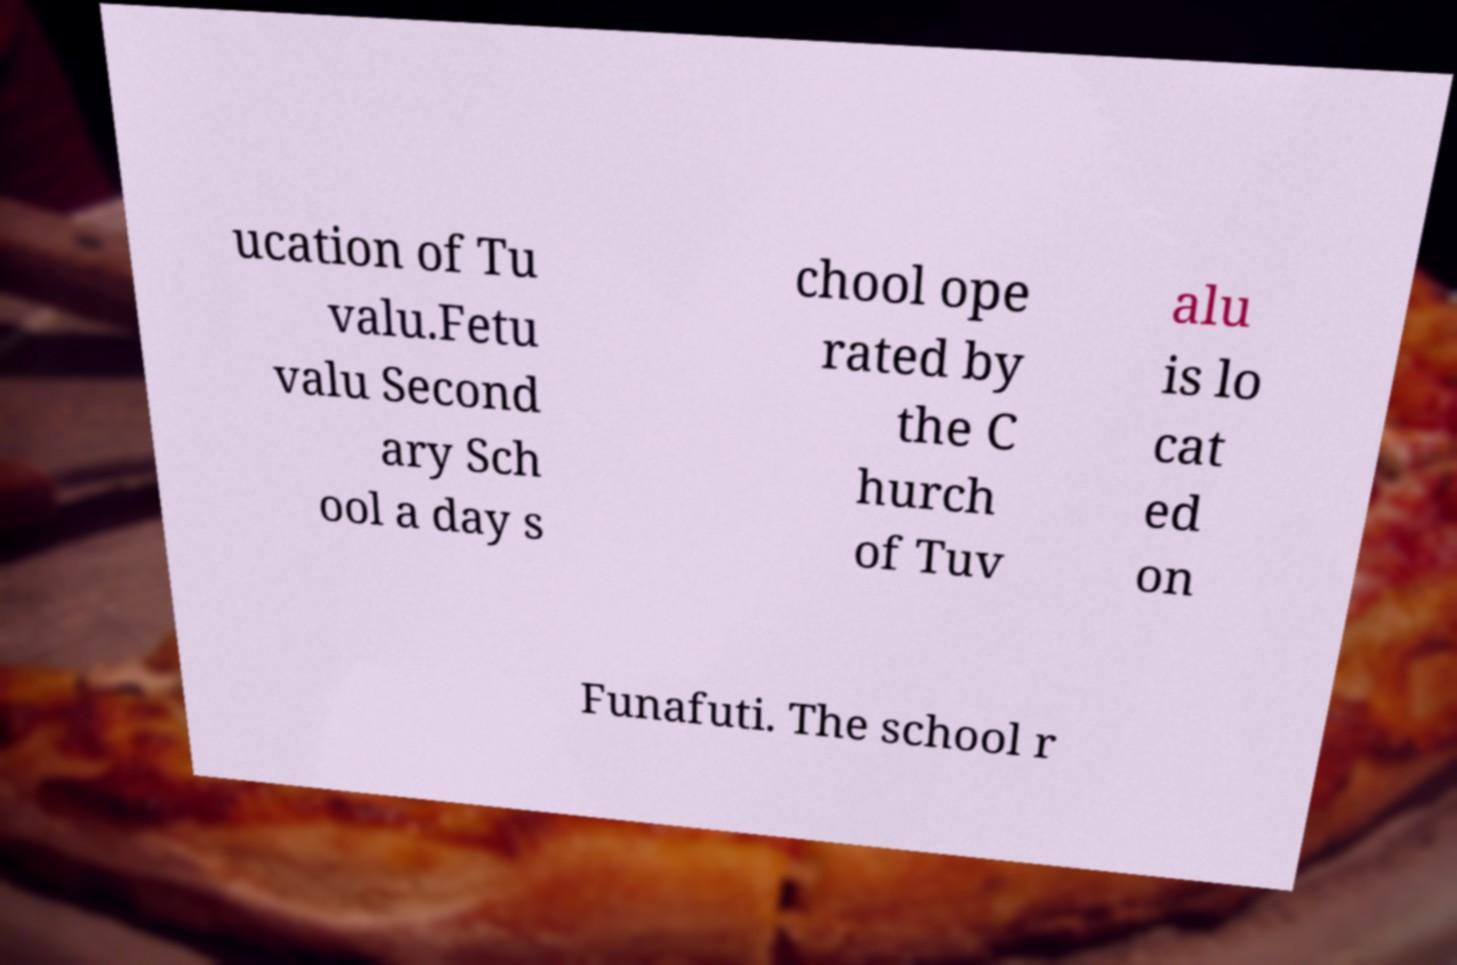Please read and relay the text visible in this image. What does it say? ucation of Tu valu.Fetu valu Second ary Sch ool a day s chool ope rated by the C hurch of Tuv alu is lo cat ed on Funafuti. The school r 